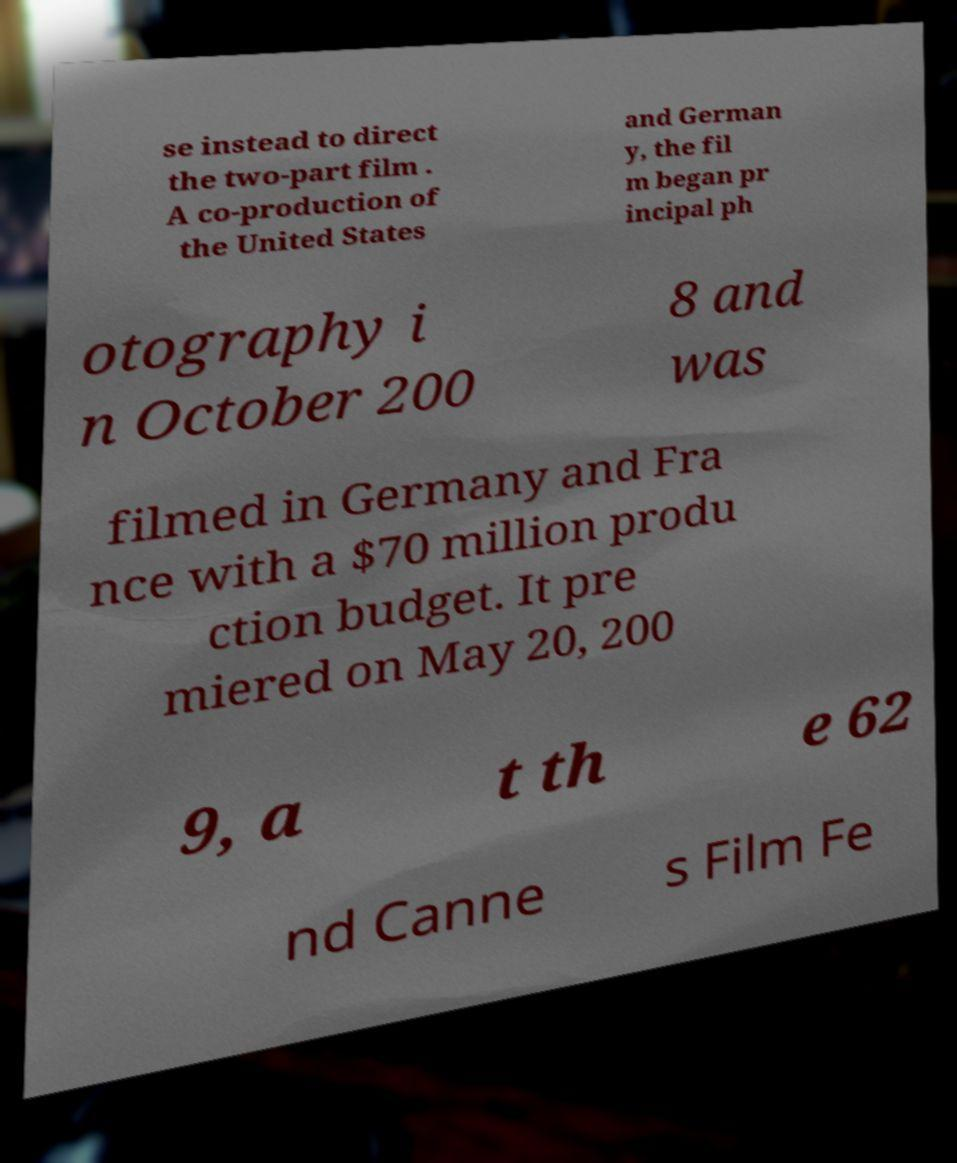Please identify and transcribe the text found in this image. se instead to direct the two-part film . A co-production of the United States and German y, the fil m began pr incipal ph otography i n October 200 8 and was filmed in Germany and Fra nce with a $70 million produ ction budget. It pre miered on May 20, 200 9, a t th e 62 nd Canne s Film Fe 